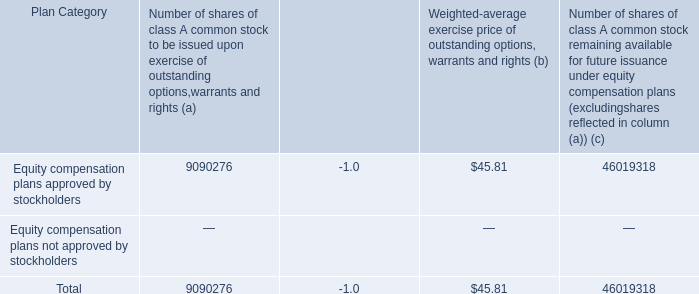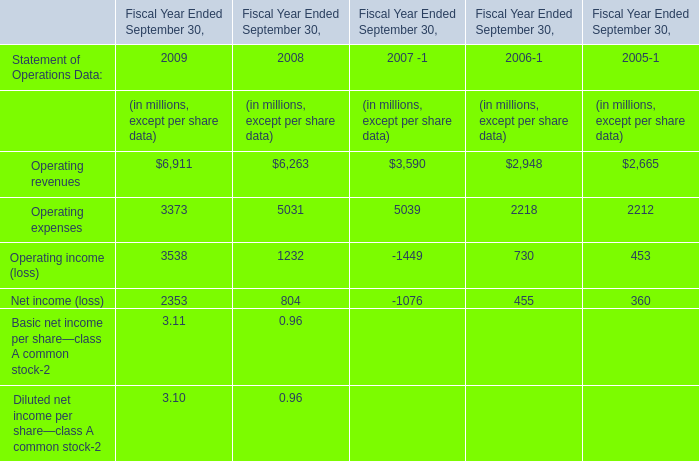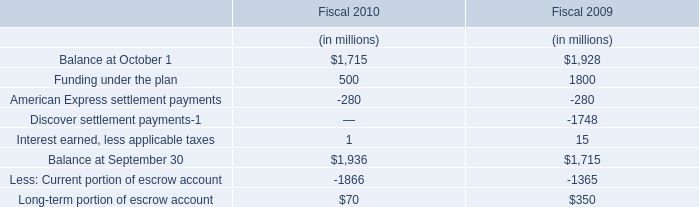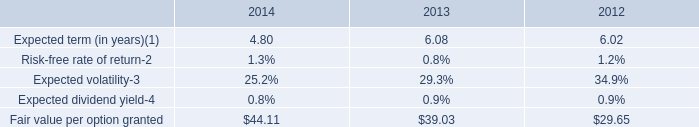What is the ratio of all operations that are smaller than 4000 to the sum of operation, in 2009? (in %) 
Computations: (((3373 + 3538) + 2353) / (((3373 + 3538) + 2353) + 6911))
Answer: 0.57274. 